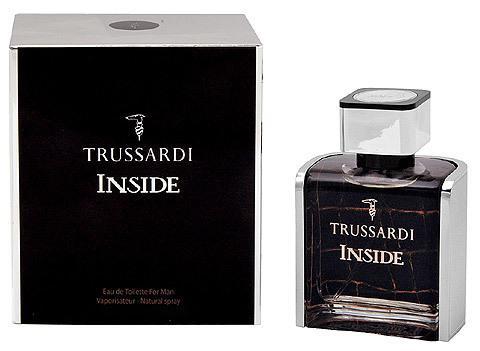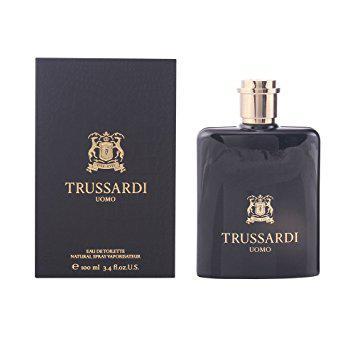The first image is the image on the left, the second image is the image on the right. Analyze the images presented: Is the assertion "Each image includes exactly two objects, and one image features an upright angled black bottle to the left of an upright angled white bottle." valid? Answer yes or no. No. 